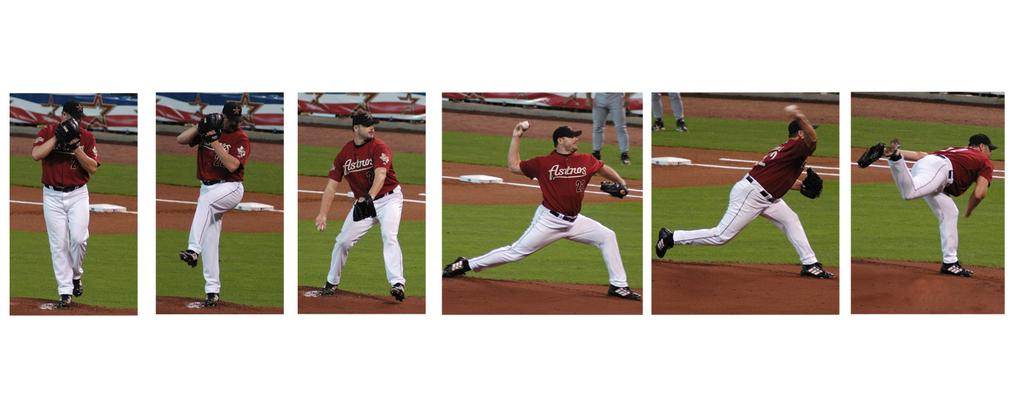<image>
Relay a brief, clear account of the picture shown. An Astros player in a red jersey can be seen throwing a pitch 